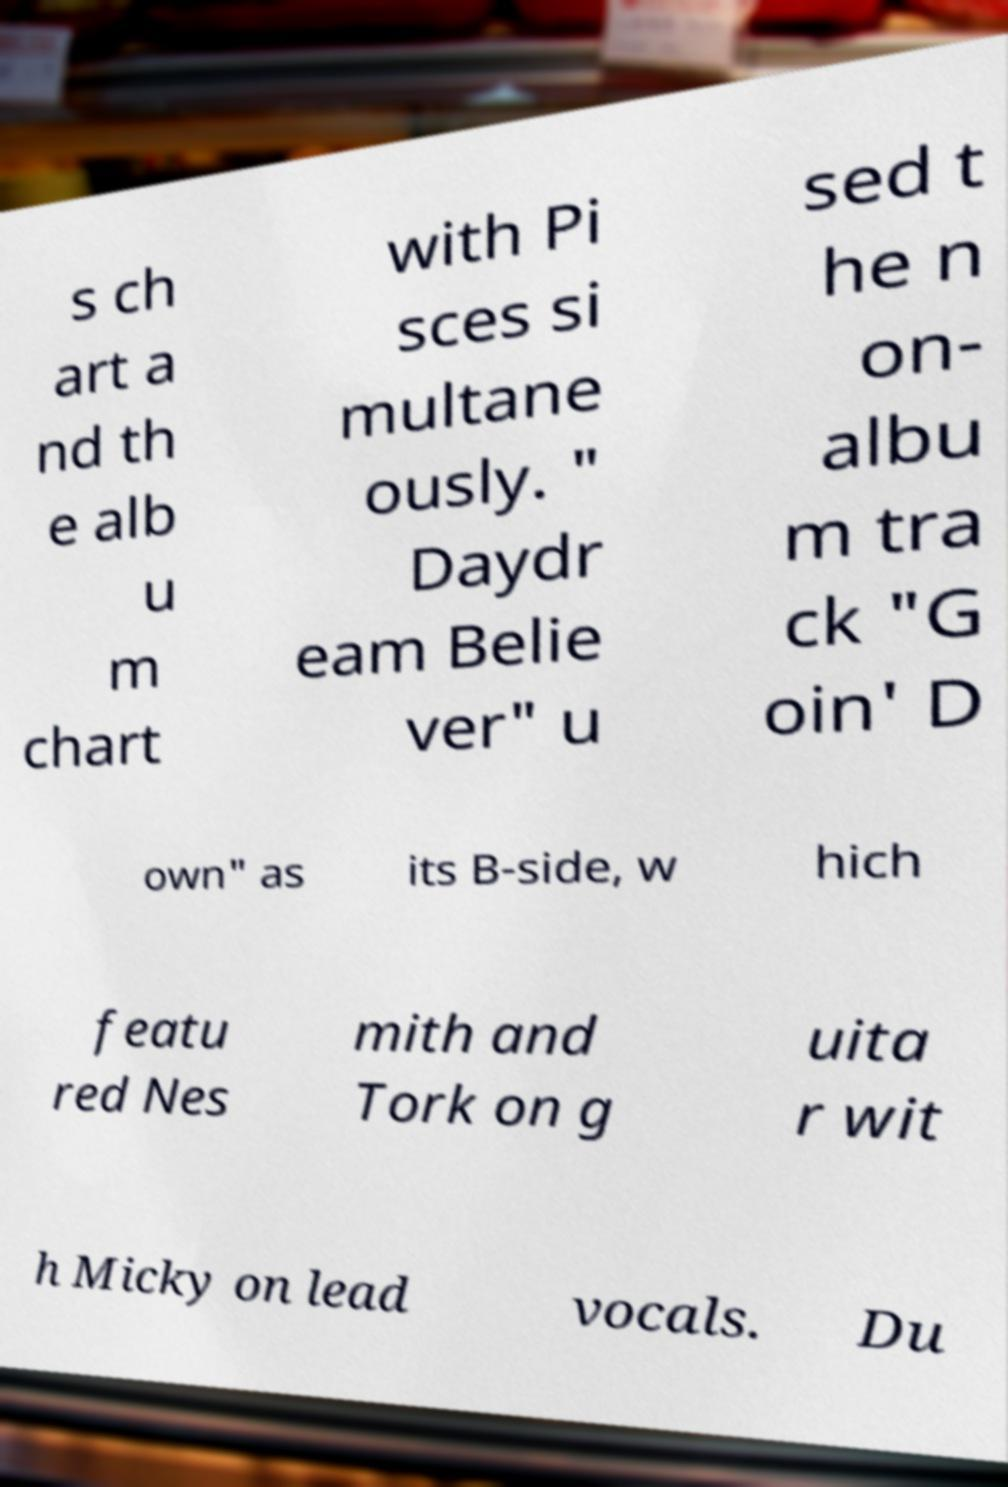I need the written content from this picture converted into text. Can you do that? s ch art a nd th e alb u m chart with Pi sces si multane ously. " Daydr eam Belie ver" u sed t he n on- albu m tra ck "G oin' D own" as its B-side, w hich featu red Nes mith and Tork on g uita r wit h Micky on lead vocals. Du 